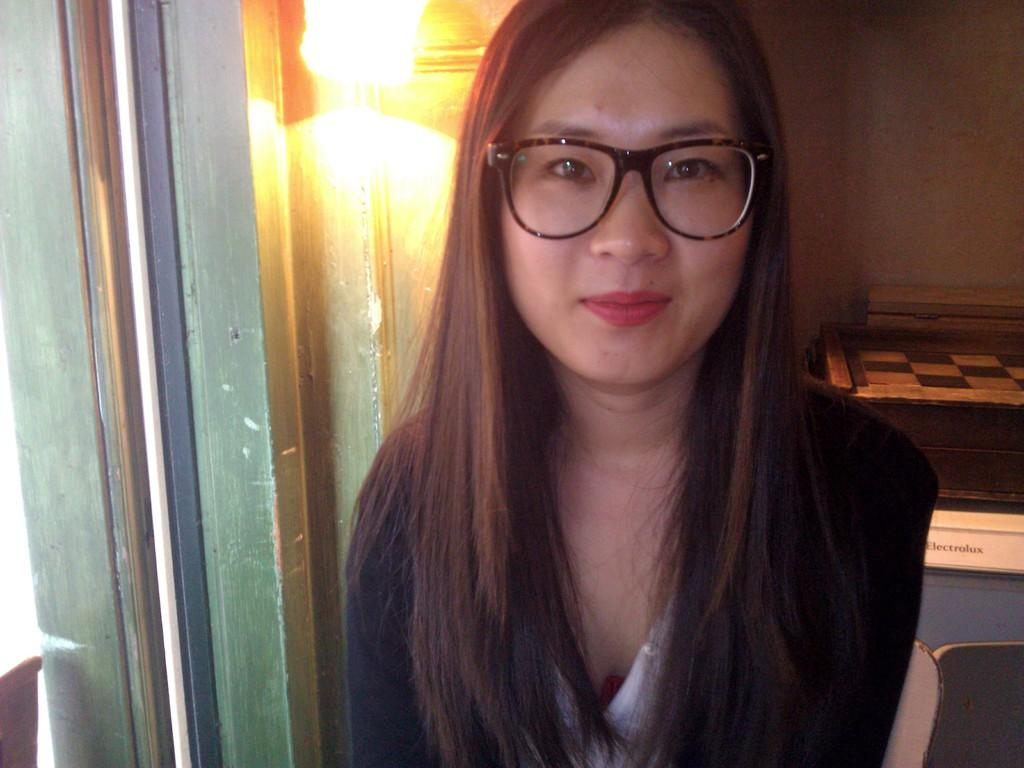Who is present in the image? There is a woman in the image. What is the woman's expression? The woman is smiling. What accessory is the woman wearing? The woman is wearing spectacles. What can be seen in the background of the image? There is a light and a wall in the background of the image. What is located on the right side of the image? There is a name board on the right side of the image. What type of cheese is the woman holding in the image? There is no cheese present in the image; the woman is not holding anything. 